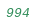Convert code to text. <code><loc_0><loc_0><loc_500><loc_500><_SQL_>
</code> 